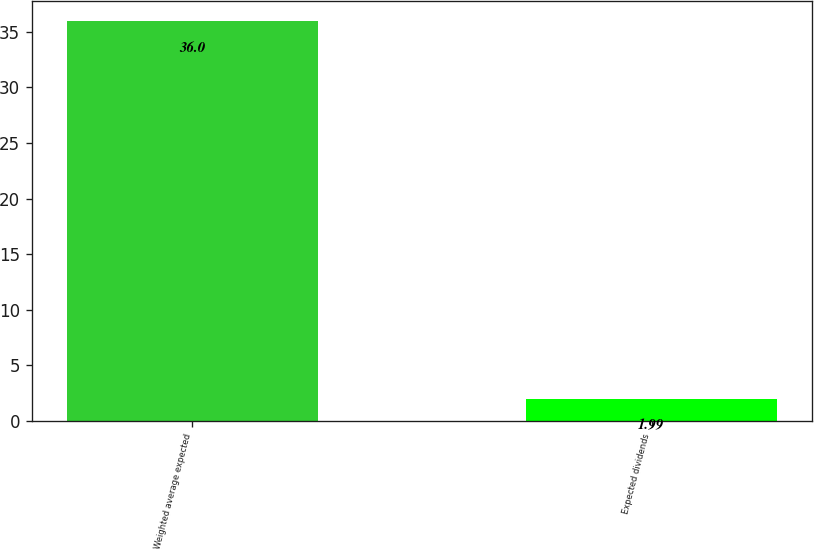Convert chart to OTSL. <chart><loc_0><loc_0><loc_500><loc_500><bar_chart><fcel>Weighted average expected<fcel>Expected dividends<nl><fcel>36<fcel>1.99<nl></chart> 